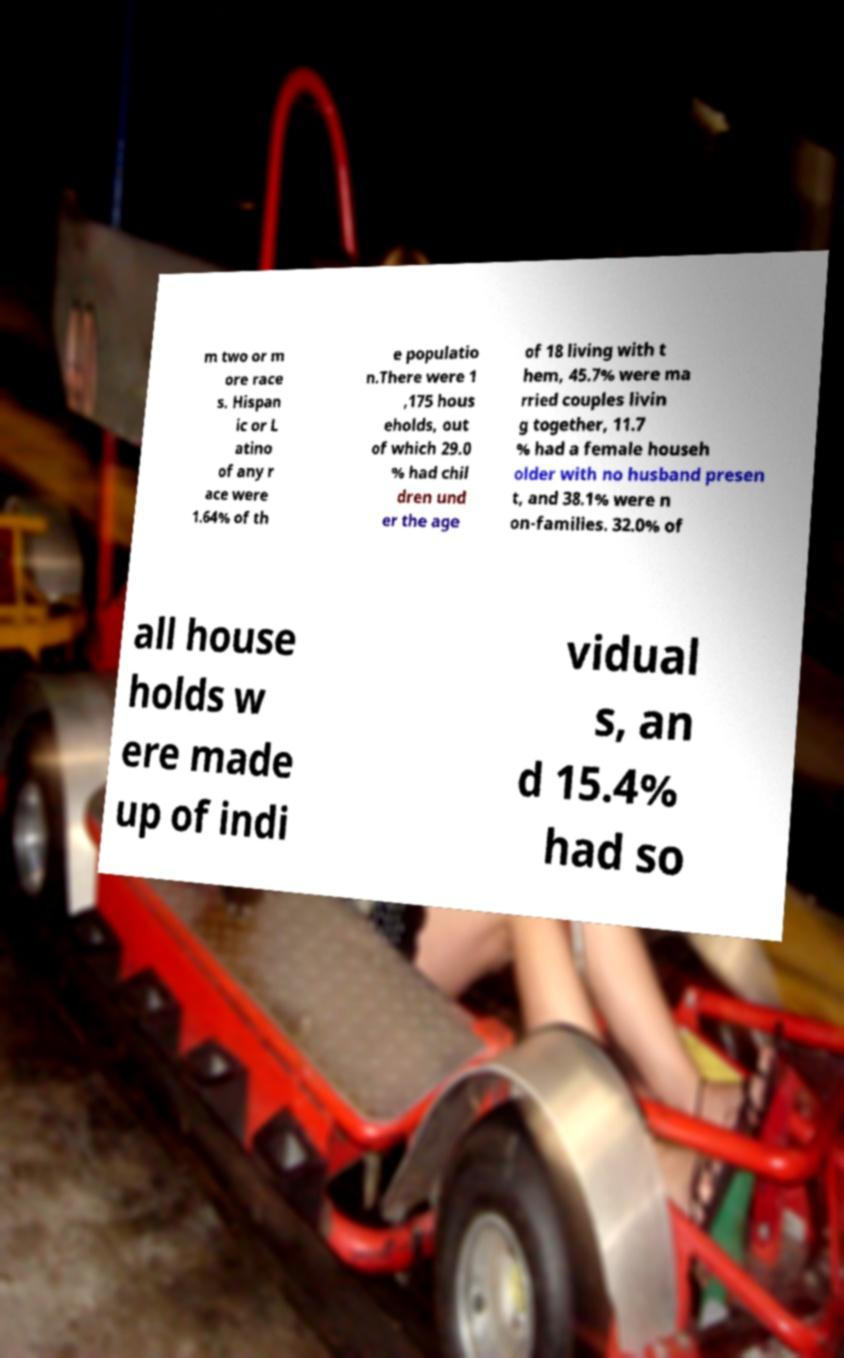Could you assist in decoding the text presented in this image and type it out clearly? m two or m ore race s. Hispan ic or L atino of any r ace were 1.64% of th e populatio n.There were 1 ,175 hous eholds, out of which 29.0 % had chil dren und er the age of 18 living with t hem, 45.7% were ma rried couples livin g together, 11.7 % had a female househ older with no husband presen t, and 38.1% were n on-families. 32.0% of all house holds w ere made up of indi vidual s, an d 15.4% had so 